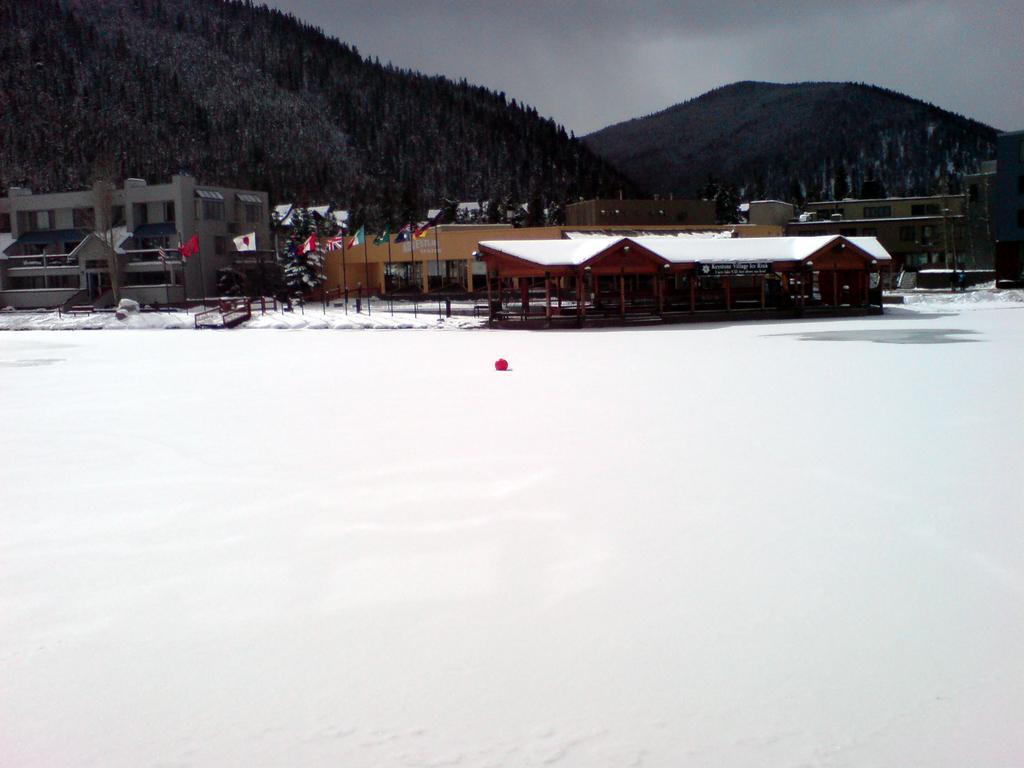How would you summarize this image in a sentence or two? In this image I can see the snow. I can see the houses. I can see the flags. In the background, I can see the hills covered with the trees and the sky. 